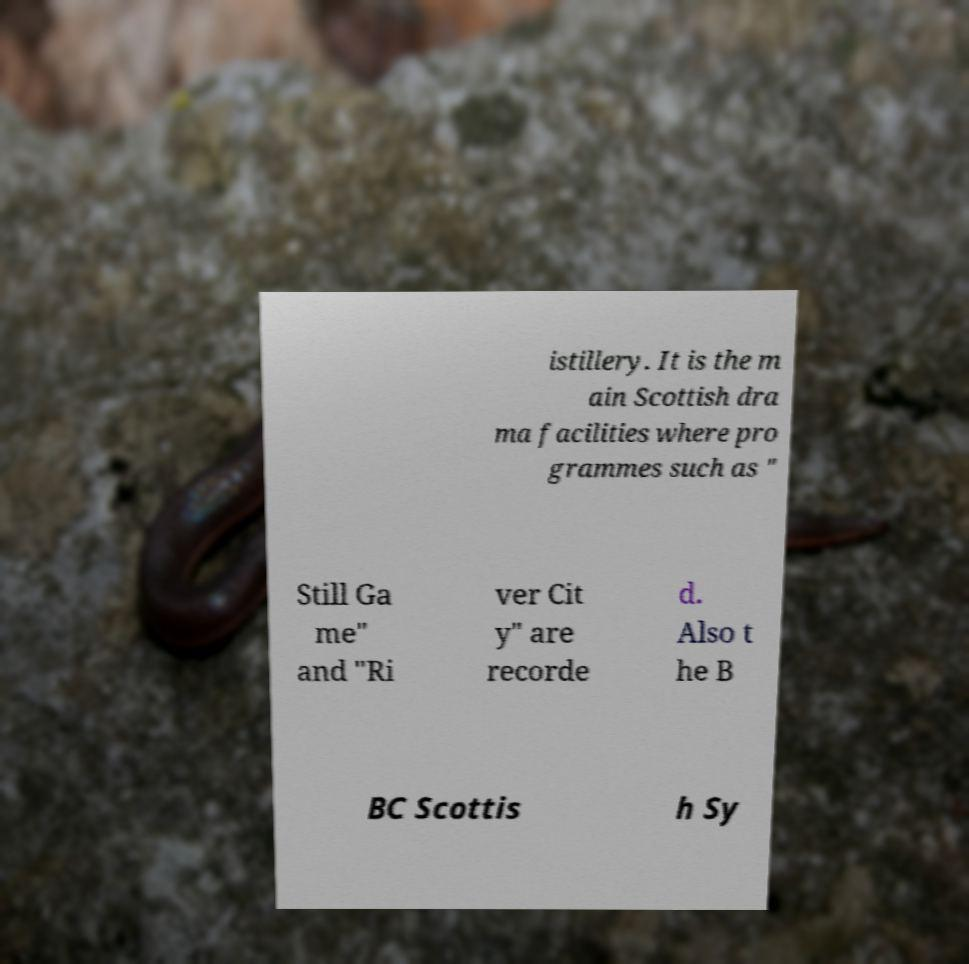There's text embedded in this image that I need extracted. Can you transcribe it verbatim? istillery. It is the m ain Scottish dra ma facilities where pro grammes such as " Still Ga me" and "Ri ver Cit y" are recorde d. Also t he B BC Scottis h Sy 